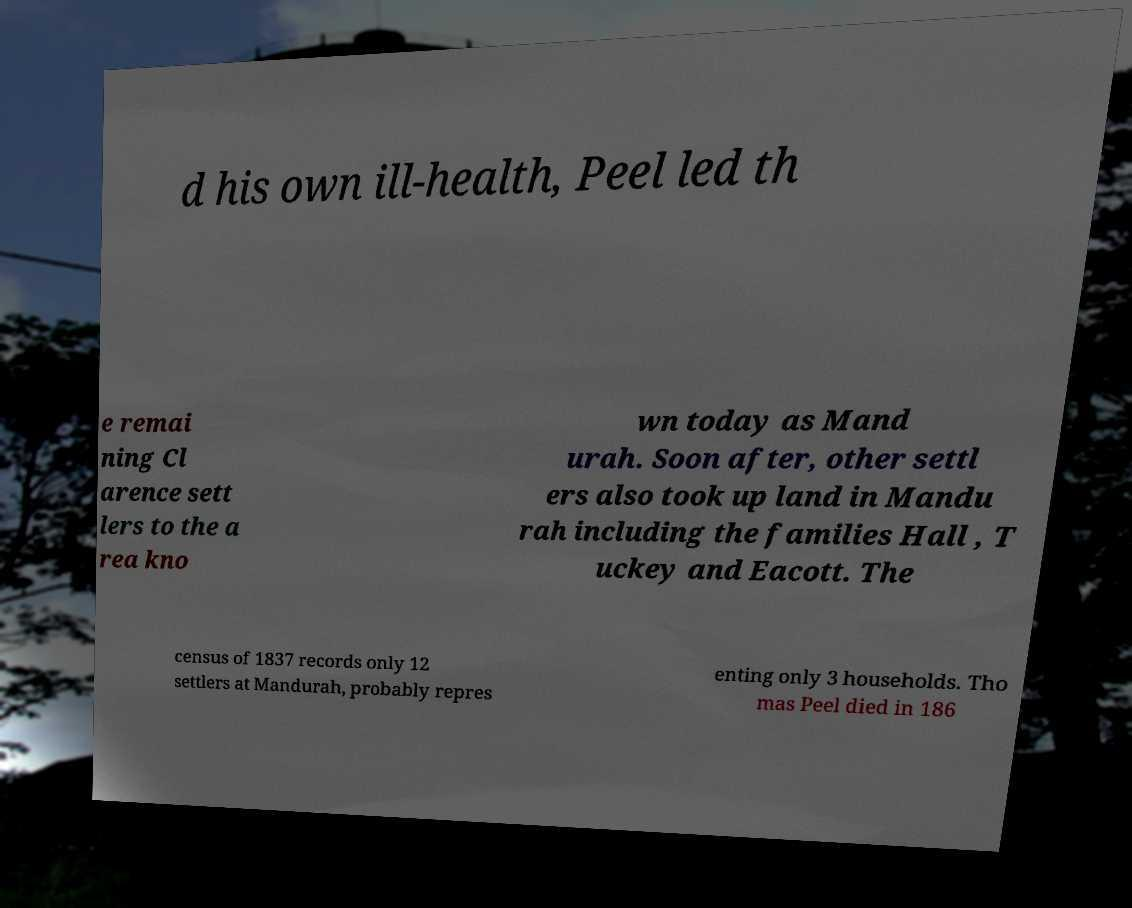Could you assist in decoding the text presented in this image and type it out clearly? d his own ill-health, Peel led th e remai ning Cl arence sett lers to the a rea kno wn today as Mand urah. Soon after, other settl ers also took up land in Mandu rah including the families Hall , T uckey and Eacott. The census of 1837 records only 12 settlers at Mandurah, probably repres enting only 3 households. Tho mas Peel died in 186 